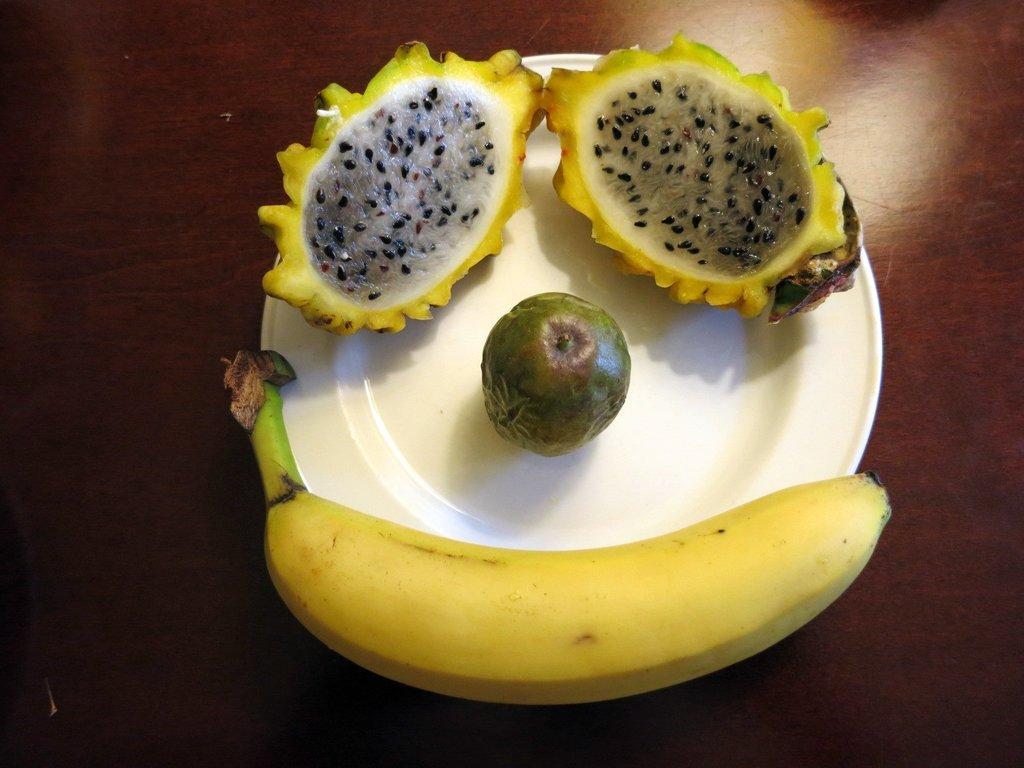In one or two sentences, can you explain what this image depicts? In this image I can see a white colour plate and on it I can see different types of fruits. 